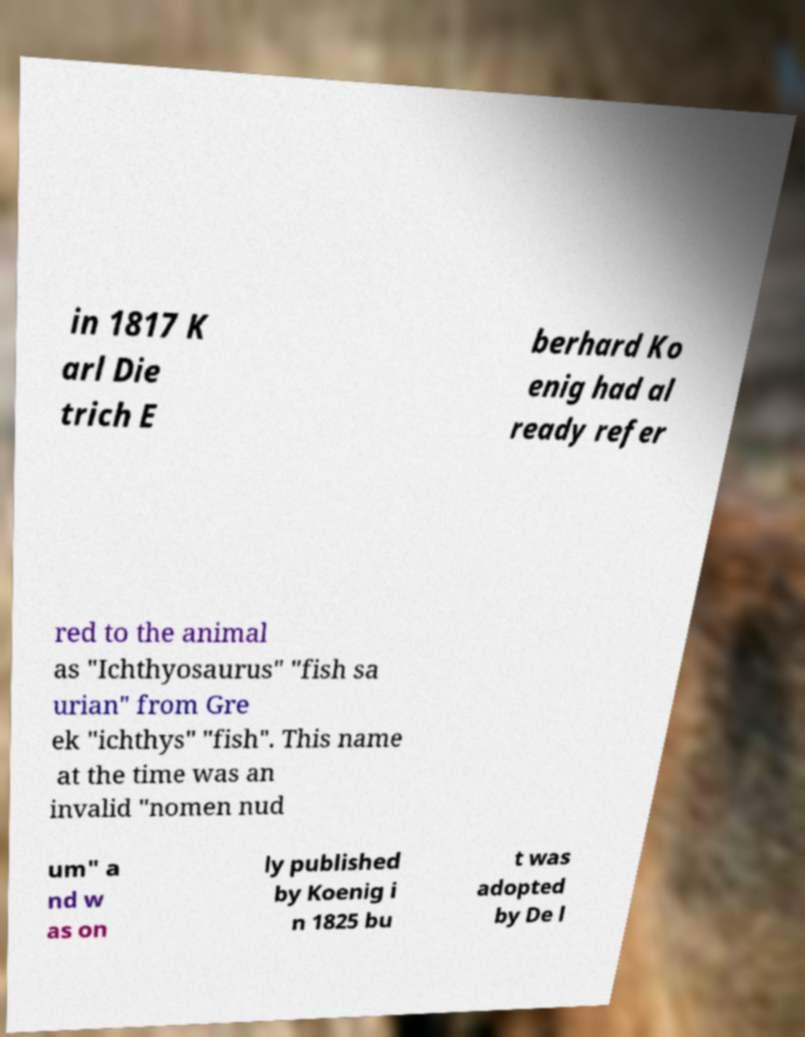There's text embedded in this image that I need extracted. Can you transcribe it verbatim? in 1817 K arl Die trich E berhard Ko enig had al ready refer red to the animal as "Ichthyosaurus" "fish sa urian" from Gre ek "ichthys" "fish". This name at the time was an invalid "nomen nud um" a nd w as on ly published by Koenig i n 1825 bu t was adopted by De l 